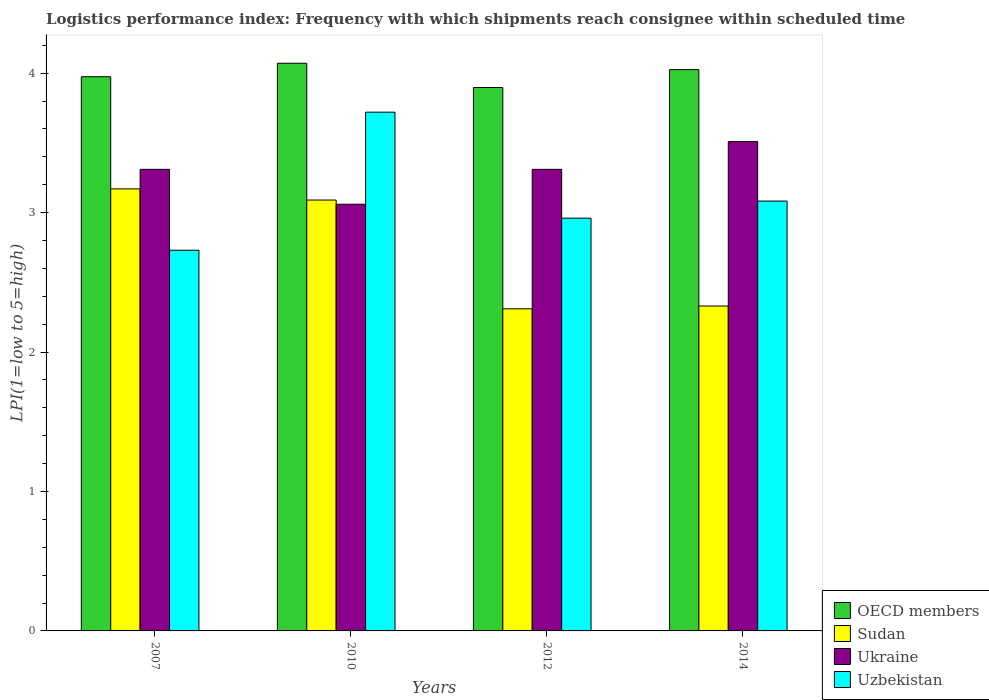How many different coloured bars are there?
Provide a short and direct response. 4. How many bars are there on the 3rd tick from the left?
Offer a terse response. 4. How many bars are there on the 3rd tick from the right?
Ensure brevity in your answer.  4. What is the logistics performance index in Ukraine in 2010?
Make the answer very short. 3.06. Across all years, what is the maximum logistics performance index in Sudan?
Ensure brevity in your answer.  3.17. Across all years, what is the minimum logistics performance index in Sudan?
Provide a succinct answer. 2.31. In which year was the logistics performance index in Ukraine maximum?
Give a very brief answer. 2014. What is the total logistics performance index in Ukraine in the graph?
Keep it short and to the point. 13.19. What is the difference between the logistics performance index in Uzbekistan in 2010 and that in 2014?
Keep it short and to the point. 0.64. What is the difference between the logistics performance index in OECD members in 2007 and the logistics performance index in Uzbekistan in 2010?
Keep it short and to the point. 0.25. What is the average logistics performance index in Sudan per year?
Provide a short and direct response. 2.73. In the year 2012, what is the difference between the logistics performance index in Uzbekistan and logistics performance index in Sudan?
Offer a very short reply. 0.65. What is the ratio of the logistics performance index in OECD members in 2010 to that in 2014?
Your response must be concise. 1.01. Is the logistics performance index in OECD members in 2007 less than that in 2010?
Provide a short and direct response. Yes. What is the difference between the highest and the second highest logistics performance index in Ukraine?
Provide a short and direct response. 0.2. What is the difference between the highest and the lowest logistics performance index in OECD members?
Your answer should be compact. 0.17. Is the sum of the logistics performance index in Sudan in 2010 and 2014 greater than the maximum logistics performance index in OECD members across all years?
Keep it short and to the point. Yes. What does the 1st bar from the left in 2012 represents?
Ensure brevity in your answer.  OECD members. Is it the case that in every year, the sum of the logistics performance index in Ukraine and logistics performance index in Uzbekistan is greater than the logistics performance index in OECD members?
Make the answer very short. Yes. Are all the bars in the graph horizontal?
Give a very brief answer. No. Does the graph contain any zero values?
Give a very brief answer. No. How are the legend labels stacked?
Make the answer very short. Vertical. What is the title of the graph?
Make the answer very short. Logistics performance index: Frequency with which shipments reach consignee within scheduled time. What is the label or title of the Y-axis?
Provide a short and direct response. LPI(1=low to 5=high). What is the LPI(1=low to 5=high) in OECD members in 2007?
Offer a terse response. 3.97. What is the LPI(1=low to 5=high) of Sudan in 2007?
Your response must be concise. 3.17. What is the LPI(1=low to 5=high) of Ukraine in 2007?
Keep it short and to the point. 3.31. What is the LPI(1=low to 5=high) of Uzbekistan in 2007?
Give a very brief answer. 2.73. What is the LPI(1=low to 5=high) of OECD members in 2010?
Offer a terse response. 4.07. What is the LPI(1=low to 5=high) in Sudan in 2010?
Make the answer very short. 3.09. What is the LPI(1=low to 5=high) of Ukraine in 2010?
Provide a short and direct response. 3.06. What is the LPI(1=low to 5=high) in Uzbekistan in 2010?
Give a very brief answer. 3.72. What is the LPI(1=low to 5=high) of OECD members in 2012?
Ensure brevity in your answer.  3.9. What is the LPI(1=low to 5=high) in Sudan in 2012?
Keep it short and to the point. 2.31. What is the LPI(1=low to 5=high) in Ukraine in 2012?
Provide a succinct answer. 3.31. What is the LPI(1=low to 5=high) in Uzbekistan in 2012?
Give a very brief answer. 2.96. What is the LPI(1=low to 5=high) of OECD members in 2014?
Give a very brief answer. 4.03. What is the LPI(1=low to 5=high) in Sudan in 2014?
Give a very brief answer. 2.33. What is the LPI(1=low to 5=high) of Ukraine in 2014?
Your response must be concise. 3.51. What is the LPI(1=low to 5=high) of Uzbekistan in 2014?
Make the answer very short. 3.08. Across all years, what is the maximum LPI(1=low to 5=high) of OECD members?
Offer a very short reply. 4.07. Across all years, what is the maximum LPI(1=low to 5=high) in Sudan?
Keep it short and to the point. 3.17. Across all years, what is the maximum LPI(1=low to 5=high) of Ukraine?
Offer a very short reply. 3.51. Across all years, what is the maximum LPI(1=low to 5=high) of Uzbekistan?
Your response must be concise. 3.72. Across all years, what is the minimum LPI(1=low to 5=high) in OECD members?
Offer a terse response. 3.9. Across all years, what is the minimum LPI(1=low to 5=high) of Sudan?
Provide a succinct answer. 2.31. Across all years, what is the minimum LPI(1=low to 5=high) of Ukraine?
Ensure brevity in your answer.  3.06. Across all years, what is the minimum LPI(1=low to 5=high) of Uzbekistan?
Make the answer very short. 2.73. What is the total LPI(1=low to 5=high) in OECD members in the graph?
Provide a succinct answer. 15.97. What is the total LPI(1=low to 5=high) of Sudan in the graph?
Ensure brevity in your answer.  10.9. What is the total LPI(1=low to 5=high) of Ukraine in the graph?
Provide a succinct answer. 13.19. What is the total LPI(1=low to 5=high) of Uzbekistan in the graph?
Keep it short and to the point. 12.49. What is the difference between the LPI(1=low to 5=high) of OECD members in 2007 and that in 2010?
Your answer should be very brief. -0.1. What is the difference between the LPI(1=low to 5=high) in Sudan in 2007 and that in 2010?
Provide a short and direct response. 0.08. What is the difference between the LPI(1=low to 5=high) of Uzbekistan in 2007 and that in 2010?
Your answer should be compact. -0.99. What is the difference between the LPI(1=low to 5=high) of OECD members in 2007 and that in 2012?
Provide a short and direct response. 0.08. What is the difference between the LPI(1=low to 5=high) in Sudan in 2007 and that in 2012?
Ensure brevity in your answer.  0.86. What is the difference between the LPI(1=low to 5=high) in Uzbekistan in 2007 and that in 2012?
Your answer should be compact. -0.23. What is the difference between the LPI(1=low to 5=high) of OECD members in 2007 and that in 2014?
Offer a terse response. -0.05. What is the difference between the LPI(1=low to 5=high) in Sudan in 2007 and that in 2014?
Give a very brief answer. 0.84. What is the difference between the LPI(1=low to 5=high) in Ukraine in 2007 and that in 2014?
Give a very brief answer. -0.2. What is the difference between the LPI(1=low to 5=high) in Uzbekistan in 2007 and that in 2014?
Give a very brief answer. -0.35. What is the difference between the LPI(1=low to 5=high) in OECD members in 2010 and that in 2012?
Your response must be concise. 0.17. What is the difference between the LPI(1=low to 5=high) in Sudan in 2010 and that in 2012?
Your answer should be compact. 0.78. What is the difference between the LPI(1=low to 5=high) in Ukraine in 2010 and that in 2012?
Provide a succinct answer. -0.25. What is the difference between the LPI(1=low to 5=high) of Uzbekistan in 2010 and that in 2012?
Make the answer very short. 0.76. What is the difference between the LPI(1=low to 5=high) of OECD members in 2010 and that in 2014?
Give a very brief answer. 0.05. What is the difference between the LPI(1=low to 5=high) of Sudan in 2010 and that in 2014?
Your answer should be very brief. 0.76. What is the difference between the LPI(1=low to 5=high) in Ukraine in 2010 and that in 2014?
Offer a very short reply. -0.45. What is the difference between the LPI(1=low to 5=high) of Uzbekistan in 2010 and that in 2014?
Provide a succinct answer. 0.64. What is the difference between the LPI(1=low to 5=high) in OECD members in 2012 and that in 2014?
Ensure brevity in your answer.  -0.13. What is the difference between the LPI(1=low to 5=high) in Sudan in 2012 and that in 2014?
Make the answer very short. -0.02. What is the difference between the LPI(1=low to 5=high) in Ukraine in 2012 and that in 2014?
Provide a succinct answer. -0.2. What is the difference between the LPI(1=low to 5=high) of Uzbekistan in 2012 and that in 2014?
Make the answer very short. -0.12. What is the difference between the LPI(1=low to 5=high) of OECD members in 2007 and the LPI(1=low to 5=high) of Sudan in 2010?
Provide a succinct answer. 0.88. What is the difference between the LPI(1=low to 5=high) of OECD members in 2007 and the LPI(1=low to 5=high) of Ukraine in 2010?
Offer a terse response. 0.91. What is the difference between the LPI(1=low to 5=high) of OECD members in 2007 and the LPI(1=low to 5=high) of Uzbekistan in 2010?
Your response must be concise. 0.25. What is the difference between the LPI(1=low to 5=high) in Sudan in 2007 and the LPI(1=low to 5=high) in Ukraine in 2010?
Your answer should be compact. 0.11. What is the difference between the LPI(1=low to 5=high) in Sudan in 2007 and the LPI(1=low to 5=high) in Uzbekistan in 2010?
Make the answer very short. -0.55. What is the difference between the LPI(1=low to 5=high) in Ukraine in 2007 and the LPI(1=low to 5=high) in Uzbekistan in 2010?
Your answer should be compact. -0.41. What is the difference between the LPI(1=low to 5=high) in OECD members in 2007 and the LPI(1=low to 5=high) in Sudan in 2012?
Your response must be concise. 1.66. What is the difference between the LPI(1=low to 5=high) in OECD members in 2007 and the LPI(1=low to 5=high) in Ukraine in 2012?
Your response must be concise. 0.66. What is the difference between the LPI(1=low to 5=high) of OECD members in 2007 and the LPI(1=low to 5=high) of Uzbekistan in 2012?
Keep it short and to the point. 1.01. What is the difference between the LPI(1=low to 5=high) of Sudan in 2007 and the LPI(1=low to 5=high) of Ukraine in 2012?
Your response must be concise. -0.14. What is the difference between the LPI(1=low to 5=high) of Sudan in 2007 and the LPI(1=low to 5=high) of Uzbekistan in 2012?
Your answer should be very brief. 0.21. What is the difference between the LPI(1=low to 5=high) in OECD members in 2007 and the LPI(1=low to 5=high) in Sudan in 2014?
Make the answer very short. 1.64. What is the difference between the LPI(1=low to 5=high) of OECD members in 2007 and the LPI(1=low to 5=high) of Ukraine in 2014?
Offer a very short reply. 0.47. What is the difference between the LPI(1=low to 5=high) of OECD members in 2007 and the LPI(1=low to 5=high) of Uzbekistan in 2014?
Your answer should be very brief. 0.89. What is the difference between the LPI(1=low to 5=high) in Sudan in 2007 and the LPI(1=low to 5=high) in Ukraine in 2014?
Provide a succinct answer. -0.34. What is the difference between the LPI(1=low to 5=high) in Sudan in 2007 and the LPI(1=low to 5=high) in Uzbekistan in 2014?
Provide a succinct answer. 0.09. What is the difference between the LPI(1=low to 5=high) of Ukraine in 2007 and the LPI(1=low to 5=high) of Uzbekistan in 2014?
Provide a succinct answer. 0.23. What is the difference between the LPI(1=low to 5=high) in OECD members in 2010 and the LPI(1=low to 5=high) in Sudan in 2012?
Your response must be concise. 1.76. What is the difference between the LPI(1=low to 5=high) in OECD members in 2010 and the LPI(1=low to 5=high) in Ukraine in 2012?
Your response must be concise. 0.76. What is the difference between the LPI(1=low to 5=high) in OECD members in 2010 and the LPI(1=low to 5=high) in Uzbekistan in 2012?
Offer a terse response. 1.11. What is the difference between the LPI(1=low to 5=high) in Sudan in 2010 and the LPI(1=low to 5=high) in Ukraine in 2012?
Your response must be concise. -0.22. What is the difference between the LPI(1=low to 5=high) of Sudan in 2010 and the LPI(1=low to 5=high) of Uzbekistan in 2012?
Your answer should be very brief. 0.13. What is the difference between the LPI(1=low to 5=high) of Ukraine in 2010 and the LPI(1=low to 5=high) of Uzbekistan in 2012?
Provide a short and direct response. 0.1. What is the difference between the LPI(1=low to 5=high) of OECD members in 2010 and the LPI(1=low to 5=high) of Sudan in 2014?
Your answer should be compact. 1.74. What is the difference between the LPI(1=low to 5=high) of OECD members in 2010 and the LPI(1=low to 5=high) of Ukraine in 2014?
Provide a short and direct response. 0.56. What is the difference between the LPI(1=low to 5=high) of OECD members in 2010 and the LPI(1=low to 5=high) of Uzbekistan in 2014?
Provide a short and direct response. 0.99. What is the difference between the LPI(1=low to 5=high) in Sudan in 2010 and the LPI(1=low to 5=high) in Ukraine in 2014?
Your answer should be compact. -0.42. What is the difference between the LPI(1=low to 5=high) of Sudan in 2010 and the LPI(1=low to 5=high) of Uzbekistan in 2014?
Offer a terse response. 0.01. What is the difference between the LPI(1=low to 5=high) of Ukraine in 2010 and the LPI(1=low to 5=high) of Uzbekistan in 2014?
Keep it short and to the point. -0.02. What is the difference between the LPI(1=low to 5=high) in OECD members in 2012 and the LPI(1=low to 5=high) in Sudan in 2014?
Ensure brevity in your answer.  1.57. What is the difference between the LPI(1=low to 5=high) in OECD members in 2012 and the LPI(1=low to 5=high) in Ukraine in 2014?
Make the answer very short. 0.39. What is the difference between the LPI(1=low to 5=high) in OECD members in 2012 and the LPI(1=low to 5=high) in Uzbekistan in 2014?
Your answer should be very brief. 0.81. What is the difference between the LPI(1=low to 5=high) of Sudan in 2012 and the LPI(1=low to 5=high) of Ukraine in 2014?
Offer a terse response. -1.2. What is the difference between the LPI(1=low to 5=high) of Sudan in 2012 and the LPI(1=low to 5=high) of Uzbekistan in 2014?
Offer a terse response. -0.77. What is the difference between the LPI(1=low to 5=high) of Ukraine in 2012 and the LPI(1=low to 5=high) of Uzbekistan in 2014?
Provide a short and direct response. 0.23. What is the average LPI(1=low to 5=high) of OECD members per year?
Offer a very short reply. 3.99. What is the average LPI(1=low to 5=high) of Sudan per year?
Offer a terse response. 2.73. What is the average LPI(1=low to 5=high) in Ukraine per year?
Offer a terse response. 3.3. What is the average LPI(1=low to 5=high) of Uzbekistan per year?
Ensure brevity in your answer.  3.12. In the year 2007, what is the difference between the LPI(1=low to 5=high) in OECD members and LPI(1=low to 5=high) in Sudan?
Offer a very short reply. 0.8. In the year 2007, what is the difference between the LPI(1=low to 5=high) in OECD members and LPI(1=low to 5=high) in Ukraine?
Make the answer very short. 0.66. In the year 2007, what is the difference between the LPI(1=low to 5=high) in OECD members and LPI(1=low to 5=high) in Uzbekistan?
Provide a short and direct response. 1.24. In the year 2007, what is the difference between the LPI(1=low to 5=high) in Sudan and LPI(1=low to 5=high) in Ukraine?
Give a very brief answer. -0.14. In the year 2007, what is the difference between the LPI(1=low to 5=high) in Sudan and LPI(1=low to 5=high) in Uzbekistan?
Offer a very short reply. 0.44. In the year 2007, what is the difference between the LPI(1=low to 5=high) in Ukraine and LPI(1=low to 5=high) in Uzbekistan?
Provide a short and direct response. 0.58. In the year 2010, what is the difference between the LPI(1=low to 5=high) of OECD members and LPI(1=low to 5=high) of Sudan?
Offer a very short reply. 0.98. In the year 2010, what is the difference between the LPI(1=low to 5=high) in OECD members and LPI(1=low to 5=high) in Ukraine?
Your answer should be very brief. 1.01. In the year 2010, what is the difference between the LPI(1=low to 5=high) in OECD members and LPI(1=low to 5=high) in Uzbekistan?
Make the answer very short. 0.35. In the year 2010, what is the difference between the LPI(1=low to 5=high) in Sudan and LPI(1=low to 5=high) in Ukraine?
Provide a succinct answer. 0.03. In the year 2010, what is the difference between the LPI(1=low to 5=high) of Sudan and LPI(1=low to 5=high) of Uzbekistan?
Give a very brief answer. -0.63. In the year 2010, what is the difference between the LPI(1=low to 5=high) in Ukraine and LPI(1=low to 5=high) in Uzbekistan?
Provide a short and direct response. -0.66. In the year 2012, what is the difference between the LPI(1=low to 5=high) in OECD members and LPI(1=low to 5=high) in Sudan?
Your answer should be compact. 1.59. In the year 2012, what is the difference between the LPI(1=low to 5=high) of OECD members and LPI(1=low to 5=high) of Ukraine?
Your response must be concise. 0.59. In the year 2012, what is the difference between the LPI(1=low to 5=high) of OECD members and LPI(1=low to 5=high) of Uzbekistan?
Give a very brief answer. 0.94. In the year 2012, what is the difference between the LPI(1=low to 5=high) in Sudan and LPI(1=low to 5=high) in Ukraine?
Offer a very short reply. -1. In the year 2012, what is the difference between the LPI(1=low to 5=high) of Sudan and LPI(1=low to 5=high) of Uzbekistan?
Your answer should be very brief. -0.65. In the year 2014, what is the difference between the LPI(1=low to 5=high) of OECD members and LPI(1=low to 5=high) of Sudan?
Your answer should be very brief. 1.7. In the year 2014, what is the difference between the LPI(1=low to 5=high) of OECD members and LPI(1=low to 5=high) of Ukraine?
Keep it short and to the point. 0.52. In the year 2014, what is the difference between the LPI(1=low to 5=high) in OECD members and LPI(1=low to 5=high) in Uzbekistan?
Ensure brevity in your answer.  0.94. In the year 2014, what is the difference between the LPI(1=low to 5=high) in Sudan and LPI(1=low to 5=high) in Ukraine?
Your response must be concise. -1.18. In the year 2014, what is the difference between the LPI(1=low to 5=high) of Sudan and LPI(1=low to 5=high) of Uzbekistan?
Offer a very short reply. -0.75. In the year 2014, what is the difference between the LPI(1=low to 5=high) of Ukraine and LPI(1=low to 5=high) of Uzbekistan?
Ensure brevity in your answer.  0.43. What is the ratio of the LPI(1=low to 5=high) of OECD members in 2007 to that in 2010?
Make the answer very short. 0.98. What is the ratio of the LPI(1=low to 5=high) in Sudan in 2007 to that in 2010?
Your answer should be compact. 1.03. What is the ratio of the LPI(1=low to 5=high) in Ukraine in 2007 to that in 2010?
Make the answer very short. 1.08. What is the ratio of the LPI(1=low to 5=high) of Uzbekistan in 2007 to that in 2010?
Provide a succinct answer. 0.73. What is the ratio of the LPI(1=low to 5=high) in OECD members in 2007 to that in 2012?
Offer a terse response. 1.02. What is the ratio of the LPI(1=low to 5=high) in Sudan in 2007 to that in 2012?
Provide a short and direct response. 1.37. What is the ratio of the LPI(1=low to 5=high) of Ukraine in 2007 to that in 2012?
Provide a succinct answer. 1. What is the ratio of the LPI(1=low to 5=high) in Uzbekistan in 2007 to that in 2012?
Offer a terse response. 0.92. What is the ratio of the LPI(1=low to 5=high) in OECD members in 2007 to that in 2014?
Offer a very short reply. 0.99. What is the ratio of the LPI(1=low to 5=high) in Sudan in 2007 to that in 2014?
Offer a terse response. 1.36. What is the ratio of the LPI(1=low to 5=high) of Ukraine in 2007 to that in 2014?
Give a very brief answer. 0.94. What is the ratio of the LPI(1=low to 5=high) in Uzbekistan in 2007 to that in 2014?
Provide a short and direct response. 0.89. What is the ratio of the LPI(1=low to 5=high) of OECD members in 2010 to that in 2012?
Ensure brevity in your answer.  1.04. What is the ratio of the LPI(1=low to 5=high) in Sudan in 2010 to that in 2012?
Offer a very short reply. 1.34. What is the ratio of the LPI(1=low to 5=high) of Ukraine in 2010 to that in 2012?
Provide a succinct answer. 0.92. What is the ratio of the LPI(1=low to 5=high) of Uzbekistan in 2010 to that in 2012?
Provide a short and direct response. 1.26. What is the ratio of the LPI(1=low to 5=high) of OECD members in 2010 to that in 2014?
Offer a terse response. 1.01. What is the ratio of the LPI(1=low to 5=high) of Sudan in 2010 to that in 2014?
Provide a succinct answer. 1.33. What is the ratio of the LPI(1=low to 5=high) in Ukraine in 2010 to that in 2014?
Offer a very short reply. 0.87. What is the ratio of the LPI(1=low to 5=high) of Uzbekistan in 2010 to that in 2014?
Ensure brevity in your answer.  1.21. What is the ratio of the LPI(1=low to 5=high) in OECD members in 2012 to that in 2014?
Ensure brevity in your answer.  0.97. What is the ratio of the LPI(1=low to 5=high) of Ukraine in 2012 to that in 2014?
Offer a terse response. 0.94. What is the ratio of the LPI(1=low to 5=high) of Uzbekistan in 2012 to that in 2014?
Your response must be concise. 0.96. What is the difference between the highest and the second highest LPI(1=low to 5=high) of OECD members?
Keep it short and to the point. 0.05. What is the difference between the highest and the second highest LPI(1=low to 5=high) in Sudan?
Give a very brief answer. 0.08. What is the difference between the highest and the second highest LPI(1=low to 5=high) in Ukraine?
Ensure brevity in your answer.  0.2. What is the difference between the highest and the second highest LPI(1=low to 5=high) in Uzbekistan?
Give a very brief answer. 0.64. What is the difference between the highest and the lowest LPI(1=low to 5=high) of OECD members?
Make the answer very short. 0.17. What is the difference between the highest and the lowest LPI(1=low to 5=high) of Sudan?
Your answer should be compact. 0.86. What is the difference between the highest and the lowest LPI(1=low to 5=high) in Ukraine?
Provide a short and direct response. 0.45. 